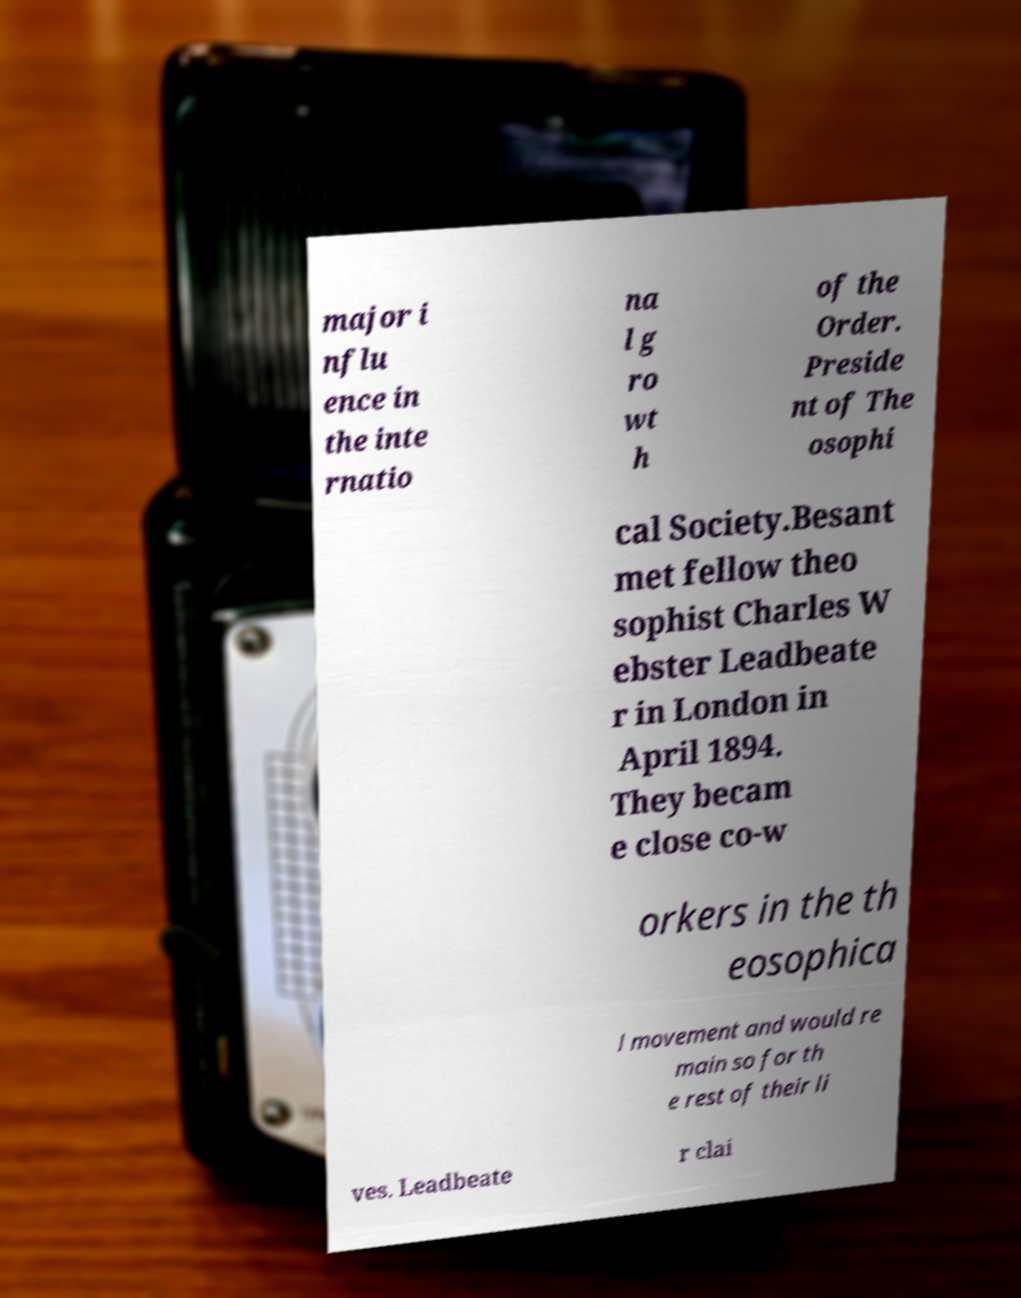I need the written content from this picture converted into text. Can you do that? major i nflu ence in the inte rnatio na l g ro wt h of the Order. Preside nt of The osophi cal Society.Besant met fellow theo sophist Charles W ebster Leadbeate r in London in April 1894. They becam e close co-w orkers in the th eosophica l movement and would re main so for th e rest of their li ves. Leadbeate r clai 